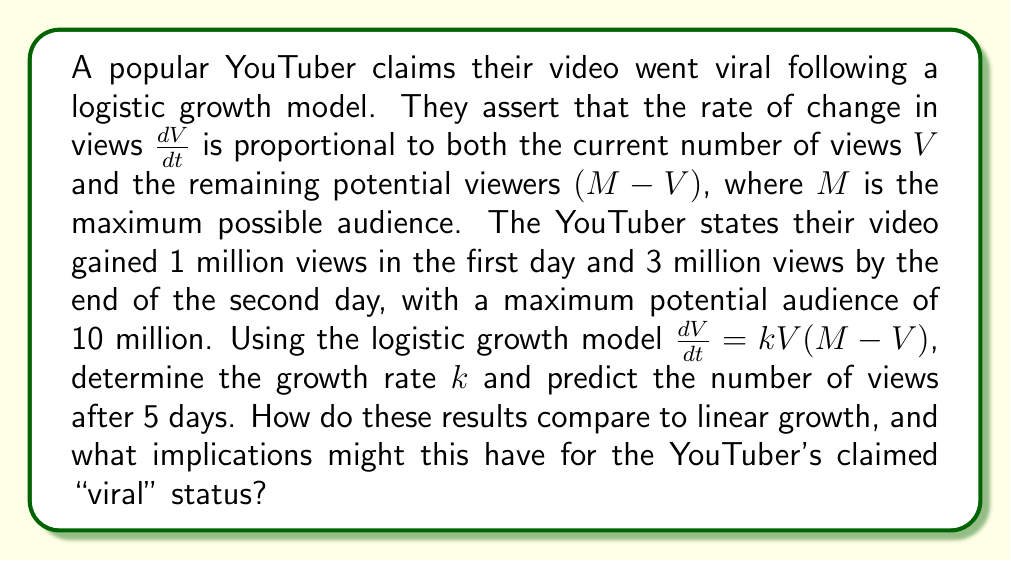Could you help me with this problem? To solve this problem, we'll follow these steps:

1) First, we need to set up the logistic growth model:

   $$\frac{dV}{dt} = kV(M-V)$$

   where $V$ is the number of views, $t$ is time in days, $k$ is the growth rate, and $M=10$ million.

2) We're given two data points:
   At $t=1$, $V=1$ million
   At $t=2$, $V=3$ million

3) To find $k$, we need to solve the differential equation. The solution to the logistic equation is:

   $$V(t) = \frac{M}{1 + Ce^{-kMt}}$$

   where $C$ is a constant we need to determine.

4) Using the initial condition $V(1)=1$, we can find $C$:

   $$1 = \frac{10}{1 + Ce^{-10k}}$$
   $$C = 9e^{10k}$$

5) Now we can use the second data point to solve for $k$:

   $$3 = \frac{10}{1 + 9e^{10k}e^{-20k}}$$
   $$3 = \frac{10}{1 + 9e^{-10k}}$$

6) Solving this equation numerically (as it's transcendental), we get:

   $$k \approx 0.2312 \text{ per million views per day}$$

7) Now that we have $k$, we can predict the views after 5 days:

   $$V(5) = \frac{10}{1 + 9e^{-10(0.2312)(5)}} \approx 8.76 \text{ million views}$$

8) Comparing to linear growth:
   Linear growth would predict $(3-1)$ million views per day after day 2, so:
   $$V_{\text{linear}}(5) = 1 + 2(5-1) = 9 \text{ million views}$$

9) The logistic model predicts slightly slower growth than the linear model at this point, which is more realistic for viral content as it accounts for saturation effects.

This analysis suggests that while the video is indeed growing rapidly, the "viral" claim should be scrutinized. The logistic model shows a more nuanced and potentially more accurate picture of growth compared to simple linear extrapolation, accounting for the natural slowing of spread as the video reaches more of its potential audience.
Answer: $k \approx 0.2312$ per million views per day; 8.76 million views after 5 days 